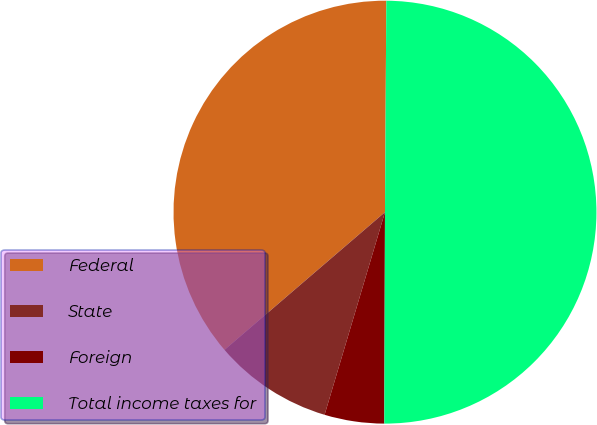Convert chart to OTSL. <chart><loc_0><loc_0><loc_500><loc_500><pie_chart><fcel>Federal<fcel>State<fcel>Foreign<fcel>Total income taxes for<nl><fcel>36.39%<fcel>9.1%<fcel>4.56%<fcel>49.95%<nl></chart> 